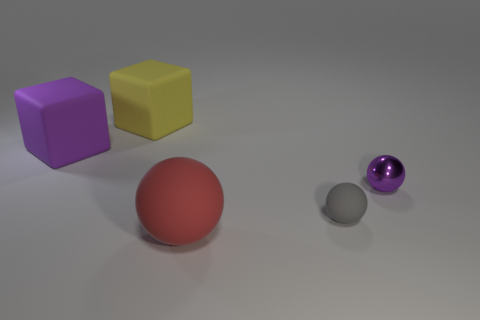Subtract all small rubber spheres. How many spheres are left? 2 Subtract all red balls. How many balls are left? 2 Subtract 3 balls. How many balls are left? 0 Add 4 purple metal balls. How many objects exist? 9 Subtract all cubes. How many objects are left? 3 Add 3 big brown rubber objects. How many big brown rubber objects exist? 3 Subtract 0 red cubes. How many objects are left? 5 Subtract all brown balls. Subtract all yellow cylinders. How many balls are left? 3 Subtract all small blue cubes. Subtract all big yellow cubes. How many objects are left? 4 Add 2 tiny things. How many tiny things are left? 4 